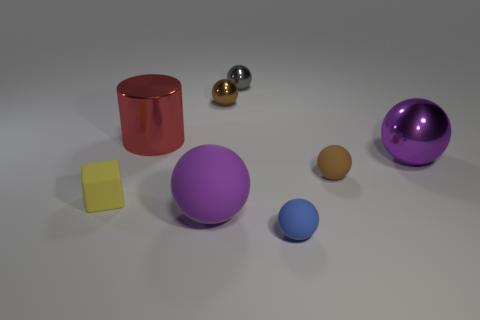Subtract all tiny gray balls. How many balls are left? 5 Add 1 large red shiny cylinders. How many objects exist? 9 Subtract all yellow cylinders. How many brown spheres are left? 2 Subtract 4 spheres. How many spheres are left? 2 Subtract all purple balls. How many balls are left? 4 Add 1 gray shiny objects. How many gray shiny objects are left? 2 Add 2 small metal objects. How many small metal objects exist? 4 Subtract 1 gray balls. How many objects are left? 7 Subtract all cylinders. How many objects are left? 7 Subtract all blue cylinders. Subtract all green cubes. How many cylinders are left? 1 